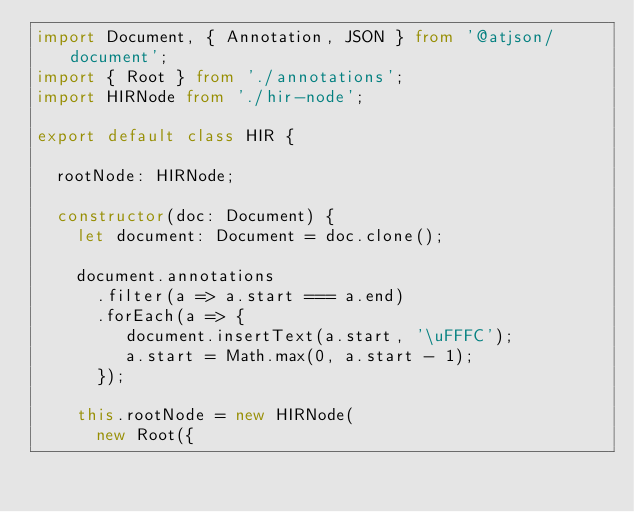<code> <loc_0><loc_0><loc_500><loc_500><_TypeScript_>import Document, { Annotation, JSON } from '@atjson/document';
import { Root } from './annotations';
import HIRNode from './hir-node';

export default class HIR {

  rootNode: HIRNode;

  constructor(doc: Document) {
    let document: Document = doc.clone();

    document.annotations
      .filter(a => a.start === a.end)
      .forEach(a => {
         document.insertText(a.start, '\uFFFC');
         a.start = Math.max(0, a.start - 1);
      });

    this.rootNode = new HIRNode(
      new Root({</code> 